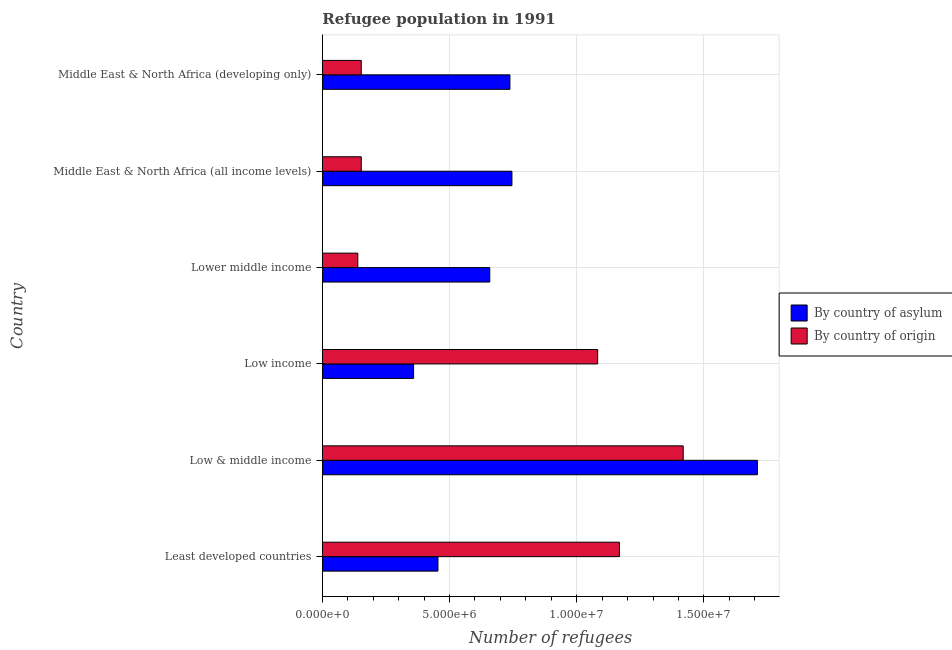Are the number of bars on each tick of the Y-axis equal?
Your response must be concise. Yes. How many bars are there on the 2nd tick from the top?
Provide a short and direct response. 2. What is the label of the 5th group of bars from the top?
Your response must be concise. Low & middle income. In how many cases, is the number of bars for a given country not equal to the number of legend labels?
Your answer should be compact. 0. What is the number of refugees by country of origin in Least developed countries?
Offer a terse response. 1.17e+07. Across all countries, what is the maximum number of refugees by country of asylum?
Your answer should be very brief. 1.71e+07. Across all countries, what is the minimum number of refugees by country of asylum?
Ensure brevity in your answer.  3.59e+06. In which country was the number of refugees by country of asylum maximum?
Your response must be concise. Low & middle income. In which country was the number of refugees by country of origin minimum?
Your answer should be very brief. Lower middle income. What is the total number of refugees by country of origin in the graph?
Offer a very short reply. 4.11e+07. What is the difference between the number of refugees by country of asylum in Low income and that in Lower middle income?
Your answer should be very brief. -2.99e+06. What is the difference between the number of refugees by country of asylum in Middle East & North Africa (all income levels) and the number of refugees by country of origin in Middle East & North Africa (developing only)?
Your response must be concise. 5.92e+06. What is the average number of refugees by country of asylum per country?
Keep it short and to the point. 7.77e+06. What is the difference between the number of refugees by country of origin and number of refugees by country of asylum in Lower middle income?
Your response must be concise. -5.19e+06. In how many countries, is the number of refugees by country of origin greater than 8000000 ?
Ensure brevity in your answer.  3. What is the ratio of the number of refugees by country of origin in Low & middle income to that in Middle East & North Africa (all income levels)?
Keep it short and to the point. 9.27. Is the difference between the number of refugees by country of asylum in Least developed countries and Middle East & North Africa (all income levels) greater than the difference between the number of refugees by country of origin in Least developed countries and Middle East & North Africa (all income levels)?
Give a very brief answer. No. What is the difference between the highest and the second highest number of refugees by country of asylum?
Give a very brief answer. 9.65e+06. What is the difference between the highest and the lowest number of refugees by country of asylum?
Keep it short and to the point. 1.35e+07. What does the 2nd bar from the top in Least developed countries represents?
Provide a short and direct response. By country of asylum. What does the 1st bar from the bottom in Lower middle income represents?
Provide a short and direct response. By country of asylum. How many bars are there?
Make the answer very short. 12. Are the values on the major ticks of X-axis written in scientific E-notation?
Give a very brief answer. Yes. Does the graph contain any zero values?
Provide a succinct answer. No. Does the graph contain grids?
Your answer should be very brief. Yes. Where does the legend appear in the graph?
Offer a terse response. Center right. How many legend labels are there?
Your response must be concise. 2. What is the title of the graph?
Provide a short and direct response. Refugee population in 1991. What is the label or title of the X-axis?
Offer a terse response. Number of refugees. What is the label or title of the Y-axis?
Offer a terse response. Country. What is the Number of refugees of By country of asylum in Least developed countries?
Your answer should be very brief. 4.54e+06. What is the Number of refugees in By country of origin in Least developed countries?
Provide a short and direct response. 1.17e+07. What is the Number of refugees in By country of asylum in Low & middle income?
Ensure brevity in your answer.  1.71e+07. What is the Number of refugees in By country of origin in Low & middle income?
Your answer should be compact. 1.42e+07. What is the Number of refugees in By country of asylum in Low income?
Your response must be concise. 3.59e+06. What is the Number of refugees in By country of origin in Low income?
Provide a short and direct response. 1.08e+07. What is the Number of refugees in By country of asylum in Lower middle income?
Give a very brief answer. 6.58e+06. What is the Number of refugees of By country of origin in Lower middle income?
Offer a terse response. 1.39e+06. What is the Number of refugees of By country of asylum in Middle East & North Africa (all income levels)?
Offer a terse response. 7.45e+06. What is the Number of refugees of By country of origin in Middle East & North Africa (all income levels)?
Ensure brevity in your answer.  1.53e+06. What is the Number of refugees in By country of asylum in Middle East & North Africa (developing only)?
Your response must be concise. 7.37e+06. What is the Number of refugees in By country of origin in Middle East & North Africa (developing only)?
Your answer should be very brief. 1.53e+06. Across all countries, what is the maximum Number of refugees of By country of asylum?
Your answer should be very brief. 1.71e+07. Across all countries, what is the maximum Number of refugees of By country of origin?
Ensure brevity in your answer.  1.42e+07. Across all countries, what is the minimum Number of refugees of By country of asylum?
Make the answer very short. 3.59e+06. Across all countries, what is the minimum Number of refugees of By country of origin?
Give a very brief answer. 1.39e+06. What is the total Number of refugees of By country of asylum in the graph?
Your response must be concise. 4.66e+07. What is the total Number of refugees in By country of origin in the graph?
Give a very brief answer. 4.11e+07. What is the difference between the Number of refugees of By country of asylum in Least developed countries and that in Low & middle income?
Your answer should be very brief. -1.26e+07. What is the difference between the Number of refugees of By country of origin in Least developed countries and that in Low & middle income?
Ensure brevity in your answer.  -2.51e+06. What is the difference between the Number of refugees in By country of asylum in Least developed countries and that in Low income?
Your answer should be compact. 9.57e+05. What is the difference between the Number of refugees of By country of origin in Least developed countries and that in Low income?
Make the answer very short. 8.55e+05. What is the difference between the Number of refugees of By country of asylum in Least developed countries and that in Lower middle income?
Your answer should be very brief. -2.04e+06. What is the difference between the Number of refugees of By country of origin in Least developed countries and that in Lower middle income?
Provide a succinct answer. 1.03e+07. What is the difference between the Number of refugees of By country of asylum in Least developed countries and that in Middle East & North Africa (all income levels)?
Provide a short and direct response. -2.91e+06. What is the difference between the Number of refugees in By country of origin in Least developed countries and that in Middle East & North Africa (all income levels)?
Keep it short and to the point. 1.01e+07. What is the difference between the Number of refugees in By country of asylum in Least developed countries and that in Middle East & North Africa (developing only)?
Ensure brevity in your answer.  -2.83e+06. What is the difference between the Number of refugees in By country of origin in Least developed countries and that in Middle East & North Africa (developing only)?
Provide a short and direct response. 1.01e+07. What is the difference between the Number of refugees of By country of asylum in Low & middle income and that in Low income?
Ensure brevity in your answer.  1.35e+07. What is the difference between the Number of refugees of By country of origin in Low & middle income and that in Low income?
Your response must be concise. 3.36e+06. What is the difference between the Number of refugees of By country of asylum in Low & middle income and that in Lower middle income?
Your response must be concise. 1.05e+07. What is the difference between the Number of refugees of By country of origin in Low & middle income and that in Lower middle income?
Provide a short and direct response. 1.28e+07. What is the difference between the Number of refugees of By country of asylum in Low & middle income and that in Middle East & North Africa (all income levels)?
Make the answer very short. 9.65e+06. What is the difference between the Number of refugees in By country of origin in Low & middle income and that in Middle East & North Africa (all income levels)?
Provide a short and direct response. 1.27e+07. What is the difference between the Number of refugees in By country of asylum in Low & middle income and that in Middle East & North Africa (developing only)?
Make the answer very short. 9.73e+06. What is the difference between the Number of refugees in By country of origin in Low & middle income and that in Middle East & North Africa (developing only)?
Offer a terse response. 1.27e+07. What is the difference between the Number of refugees of By country of asylum in Low income and that in Lower middle income?
Provide a short and direct response. -2.99e+06. What is the difference between the Number of refugees in By country of origin in Low income and that in Lower middle income?
Provide a short and direct response. 9.43e+06. What is the difference between the Number of refugees in By country of asylum in Low income and that in Middle East & North Africa (all income levels)?
Keep it short and to the point. -3.86e+06. What is the difference between the Number of refugees in By country of origin in Low income and that in Middle East & North Africa (all income levels)?
Keep it short and to the point. 9.29e+06. What is the difference between the Number of refugees of By country of asylum in Low income and that in Middle East & North Africa (developing only)?
Your answer should be very brief. -3.79e+06. What is the difference between the Number of refugees in By country of origin in Low income and that in Middle East & North Africa (developing only)?
Your answer should be very brief. 9.29e+06. What is the difference between the Number of refugees in By country of asylum in Lower middle income and that in Middle East & North Africa (all income levels)?
Give a very brief answer. -8.71e+05. What is the difference between the Number of refugees of By country of origin in Lower middle income and that in Middle East & North Africa (all income levels)?
Your response must be concise. -1.36e+05. What is the difference between the Number of refugees in By country of asylum in Lower middle income and that in Middle East & North Africa (developing only)?
Keep it short and to the point. -7.92e+05. What is the difference between the Number of refugees in By country of origin in Lower middle income and that in Middle East & North Africa (developing only)?
Give a very brief answer. -1.36e+05. What is the difference between the Number of refugees in By country of asylum in Middle East & North Africa (all income levels) and that in Middle East & North Africa (developing only)?
Provide a short and direct response. 7.89e+04. What is the difference between the Number of refugees in By country of origin in Middle East & North Africa (all income levels) and that in Middle East & North Africa (developing only)?
Provide a succinct answer. 128. What is the difference between the Number of refugees of By country of asylum in Least developed countries and the Number of refugees of By country of origin in Low & middle income?
Ensure brevity in your answer.  -9.64e+06. What is the difference between the Number of refugees in By country of asylum in Least developed countries and the Number of refugees in By country of origin in Low income?
Keep it short and to the point. -6.28e+06. What is the difference between the Number of refugees in By country of asylum in Least developed countries and the Number of refugees in By country of origin in Lower middle income?
Your response must be concise. 3.15e+06. What is the difference between the Number of refugees in By country of asylum in Least developed countries and the Number of refugees in By country of origin in Middle East & North Africa (all income levels)?
Your answer should be very brief. 3.01e+06. What is the difference between the Number of refugees in By country of asylum in Least developed countries and the Number of refugees in By country of origin in Middle East & North Africa (developing only)?
Keep it short and to the point. 3.01e+06. What is the difference between the Number of refugees of By country of asylum in Low & middle income and the Number of refugees of By country of origin in Low income?
Ensure brevity in your answer.  6.28e+06. What is the difference between the Number of refugees in By country of asylum in Low & middle income and the Number of refugees in By country of origin in Lower middle income?
Your response must be concise. 1.57e+07. What is the difference between the Number of refugees of By country of asylum in Low & middle income and the Number of refugees of By country of origin in Middle East & North Africa (all income levels)?
Your answer should be very brief. 1.56e+07. What is the difference between the Number of refugees of By country of asylum in Low & middle income and the Number of refugees of By country of origin in Middle East & North Africa (developing only)?
Provide a short and direct response. 1.56e+07. What is the difference between the Number of refugees of By country of asylum in Low income and the Number of refugees of By country of origin in Lower middle income?
Your answer should be compact. 2.19e+06. What is the difference between the Number of refugees in By country of asylum in Low income and the Number of refugees in By country of origin in Middle East & North Africa (all income levels)?
Your response must be concise. 2.06e+06. What is the difference between the Number of refugees in By country of asylum in Low income and the Number of refugees in By country of origin in Middle East & North Africa (developing only)?
Give a very brief answer. 2.06e+06. What is the difference between the Number of refugees in By country of asylum in Lower middle income and the Number of refugees in By country of origin in Middle East & North Africa (all income levels)?
Make the answer very short. 5.05e+06. What is the difference between the Number of refugees of By country of asylum in Lower middle income and the Number of refugees of By country of origin in Middle East & North Africa (developing only)?
Provide a short and direct response. 5.05e+06. What is the difference between the Number of refugees in By country of asylum in Middle East & North Africa (all income levels) and the Number of refugees in By country of origin in Middle East & North Africa (developing only)?
Your answer should be very brief. 5.92e+06. What is the average Number of refugees of By country of asylum per country?
Provide a succinct answer. 7.77e+06. What is the average Number of refugees in By country of origin per country?
Your answer should be very brief. 6.86e+06. What is the difference between the Number of refugees of By country of asylum and Number of refugees of By country of origin in Least developed countries?
Ensure brevity in your answer.  -7.13e+06. What is the difference between the Number of refugees of By country of asylum and Number of refugees of By country of origin in Low & middle income?
Your answer should be very brief. 2.92e+06. What is the difference between the Number of refugees of By country of asylum and Number of refugees of By country of origin in Low income?
Give a very brief answer. -7.23e+06. What is the difference between the Number of refugees in By country of asylum and Number of refugees in By country of origin in Lower middle income?
Your answer should be very brief. 5.19e+06. What is the difference between the Number of refugees in By country of asylum and Number of refugees in By country of origin in Middle East & North Africa (all income levels)?
Provide a succinct answer. 5.92e+06. What is the difference between the Number of refugees of By country of asylum and Number of refugees of By country of origin in Middle East & North Africa (developing only)?
Offer a very short reply. 5.84e+06. What is the ratio of the Number of refugees in By country of asylum in Least developed countries to that in Low & middle income?
Keep it short and to the point. 0.27. What is the ratio of the Number of refugees of By country of origin in Least developed countries to that in Low & middle income?
Provide a succinct answer. 0.82. What is the ratio of the Number of refugees of By country of asylum in Least developed countries to that in Low income?
Give a very brief answer. 1.27. What is the ratio of the Number of refugees of By country of origin in Least developed countries to that in Low income?
Your answer should be very brief. 1.08. What is the ratio of the Number of refugees of By country of asylum in Least developed countries to that in Lower middle income?
Provide a succinct answer. 0.69. What is the ratio of the Number of refugees in By country of origin in Least developed countries to that in Lower middle income?
Make the answer very short. 8.37. What is the ratio of the Number of refugees in By country of asylum in Least developed countries to that in Middle East & North Africa (all income levels)?
Offer a very short reply. 0.61. What is the ratio of the Number of refugees in By country of origin in Least developed countries to that in Middle East & North Africa (all income levels)?
Offer a terse response. 7.63. What is the ratio of the Number of refugees in By country of asylum in Least developed countries to that in Middle East & North Africa (developing only)?
Make the answer very short. 0.62. What is the ratio of the Number of refugees in By country of origin in Least developed countries to that in Middle East & North Africa (developing only)?
Offer a terse response. 7.63. What is the ratio of the Number of refugees of By country of asylum in Low & middle income to that in Low income?
Give a very brief answer. 4.77. What is the ratio of the Number of refugees in By country of origin in Low & middle income to that in Low income?
Your answer should be very brief. 1.31. What is the ratio of the Number of refugees of By country of asylum in Low & middle income to that in Lower middle income?
Keep it short and to the point. 2.6. What is the ratio of the Number of refugees in By country of origin in Low & middle income to that in Lower middle income?
Offer a very short reply. 10.17. What is the ratio of the Number of refugees of By country of asylum in Low & middle income to that in Middle East & North Africa (all income levels)?
Your answer should be very brief. 2.29. What is the ratio of the Number of refugees of By country of origin in Low & middle income to that in Middle East & North Africa (all income levels)?
Offer a terse response. 9.27. What is the ratio of the Number of refugees in By country of asylum in Low & middle income to that in Middle East & North Africa (developing only)?
Ensure brevity in your answer.  2.32. What is the ratio of the Number of refugees in By country of origin in Low & middle income to that in Middle East & North Africa (developing only)?
Your answer should be very brief. 9.27. What is the ratio of the Number of refugees of By country of asylum in Low income to that in Lower middle income?
Keep it short and to the point. 0.55. What is the ratio of the Number of refugees of By country of origin in Low income to that in Lower middle income?
Your answer should be very brief. 7.76. What is the ratio of the Number of refugees in By country of asylum in Low income to that in Middle East & North Africa (all income levels)?
Make the answer very short. 0.48. What is the ratio of the Number of refugees of By country of origin in Low income to that in Middle East & North Africa (all income levels)?
Give a very brief answer. 7.07. What is the ratio of the Number of refugees of By country of asylum in Low income to that in Middle East & North Africa (developing only)?
Provide a short and direct response. 0.49. What is the ratio of the Number of refugees of By country of origin in Low income to that in Middle East & North Africa (developing only)?
Your response must be concise. 7.07. What is the ratio of the Number of refugees of By country of asylum in Lower middle income to that in Middle East & North Africa (all income levels)?
Keep it short and to the point. 0.88. What is the ratio of the Number of refugees in By country of origin in Lower middle income to that in Middle East & North Africa (all income levels)?
Offer a very short reply. 0.91. What is the ratio of the Number of refugees in By country of asylum in Lower middle income to that in Middle East & North Africa (developing only)?
Your answer should be very brief. 0.89. What is the ratio of the Number of refugees in By country of origin in Lower middle income to that in Middle East & North Africa (developing only)?
Keep it short and to the point. 0.91. What is the ratio of the Number of refugees in By country of asylum in Middle East & North Africa (all income levels) to that in Middle East & North Africa (developing only)?
Your answer should be compact. 1.01. What is the ratio of the Number of refugees in By country of origin in Middle East & North Africa (all income levels) to that in Middle East & North Africa (developing only)?
Your answer should be very brief. 1. What is the difference between the highest and the second highest Number of refugees of By country of asylum?
Make the answer very short. 9.65e+06. What is the difference between the highest and the second highest Number of refugees in By country of origin?
Keep it short and to the point. 2.51e+06. What is the difference between the highest and the lowest Number of refugees in By country of asylum?
Your answer should be compact. 1.35e+07. What is the difference between the highest and the lowest Number of refugees in By country of origin?
Provide a succinct answer. 1.28e+07. 